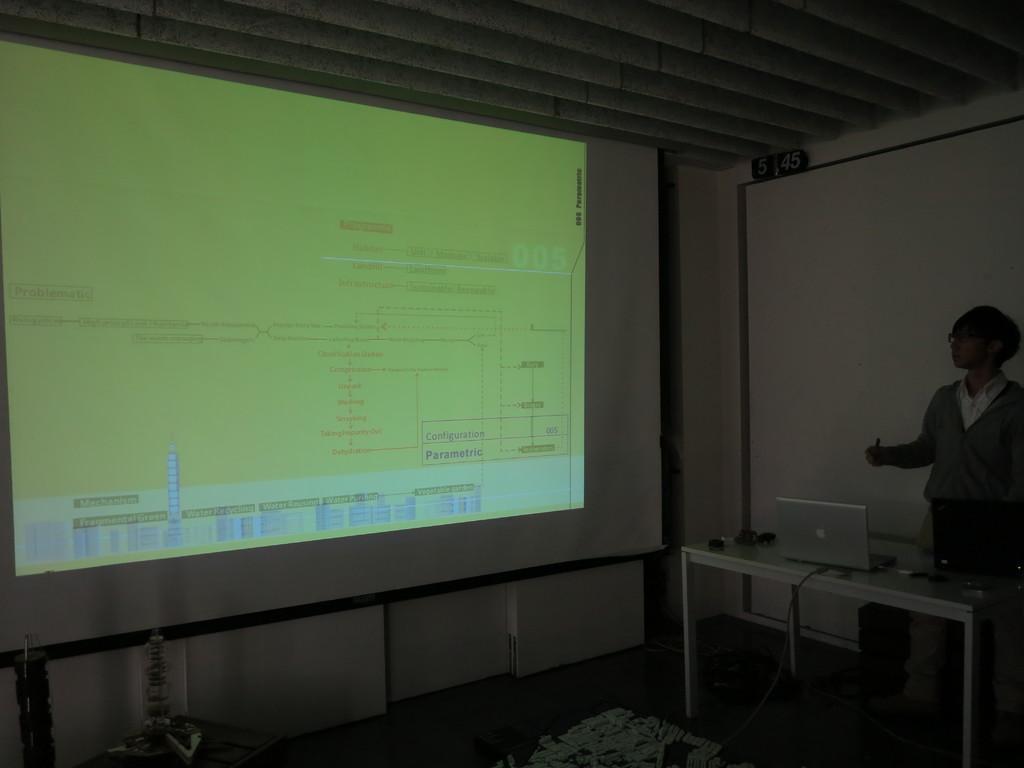How would you summarize this image in a sentence or two? Here is a man standing. This is a table with a laptop and some objects on it. This is a screen with some display. this is the rooftop. 